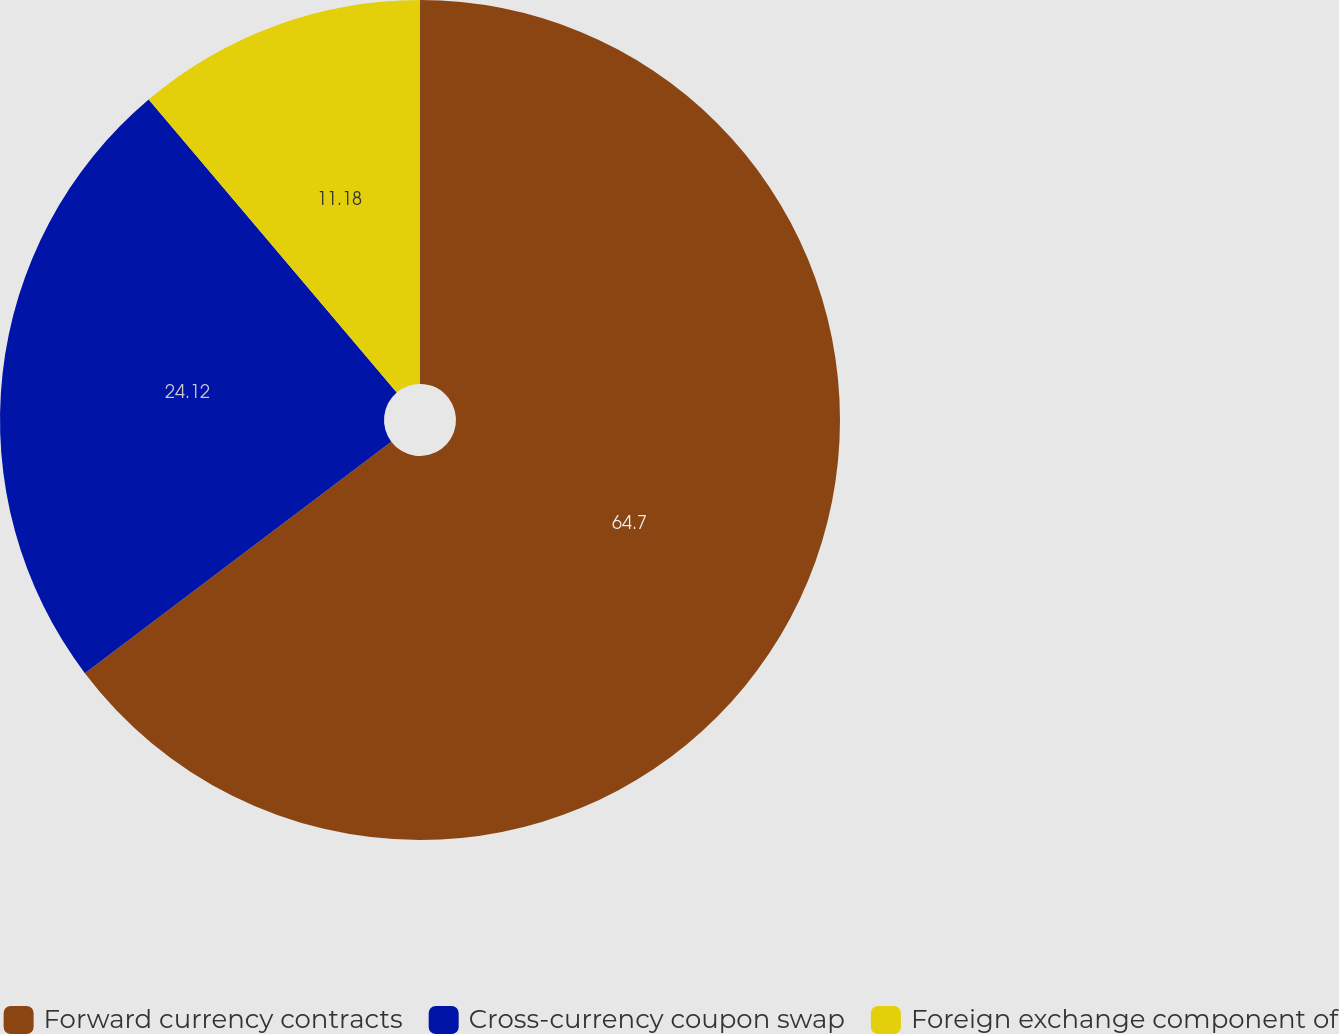Convert chart. <chart><loc_0><loc_0><loc_500><loc_500><pie_chart><fcel>Forward currency contracts<fcel>Cross-currency coupon swap<fcel>Foreign exchange component of<nl><fcel>64.71%<fcel>24.12%<fcel>11.18%<nl></chart> 